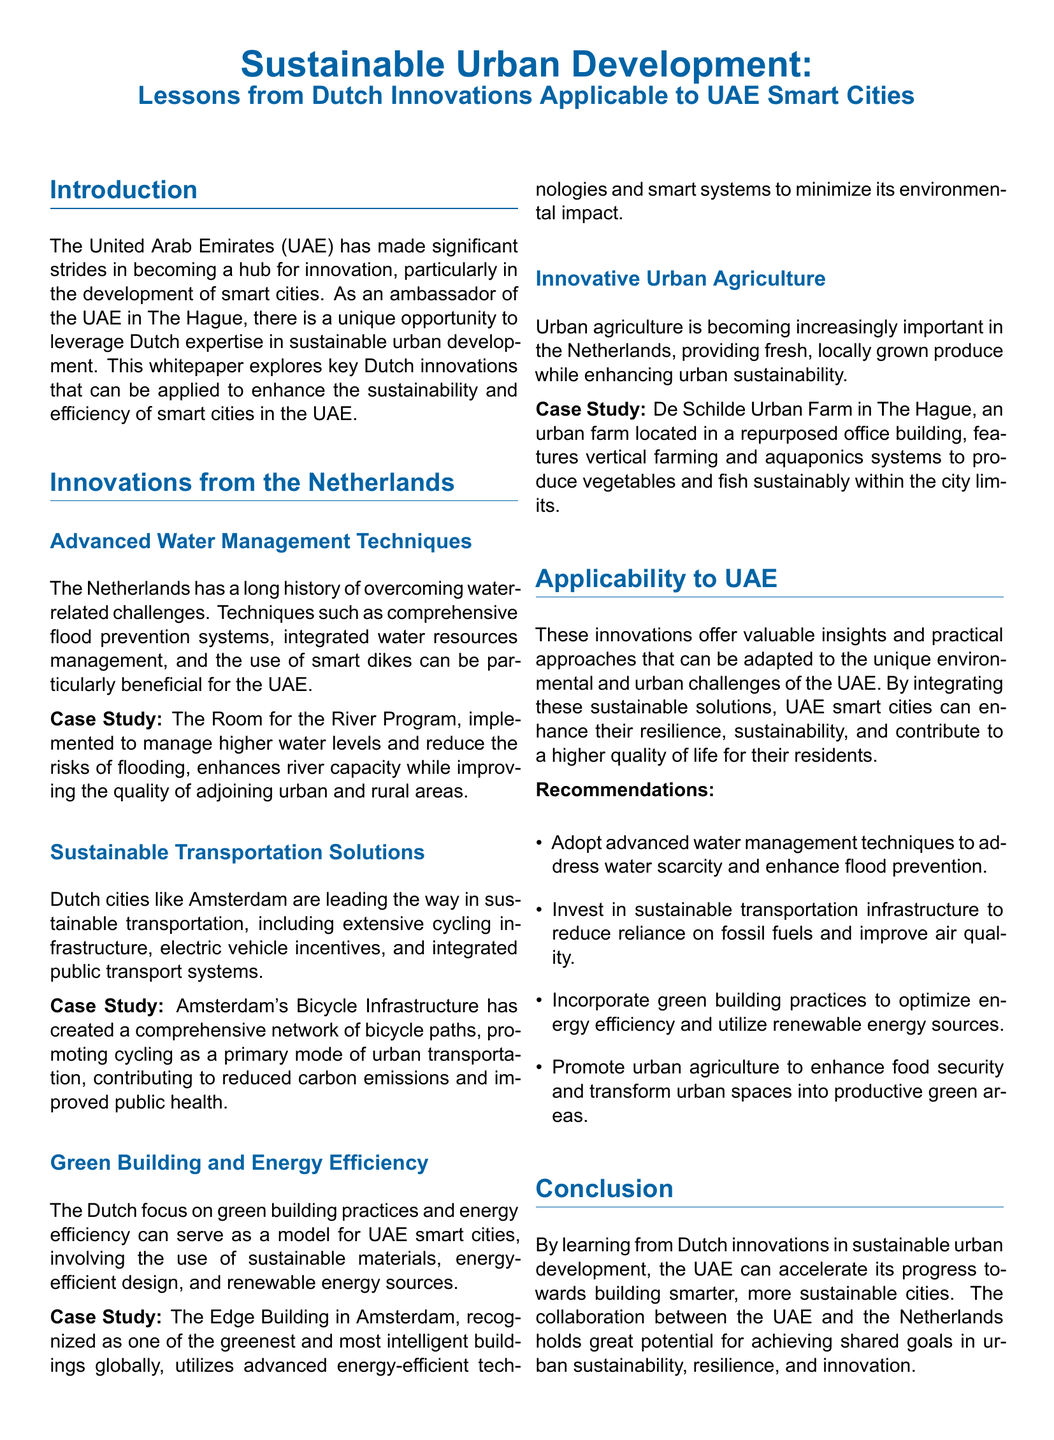What is the focus of the whitepaper? The whitepaper focuses on sustainable urban development and Dutch innovations applicable to UAE smart cities.
Answer: Sustainable urban development Which Dutch city is mentioned for its sustainable transportation solutions? The document cites Amsterdam as a leading city in sustainable transportation.
Answer: Amsterdam What advanced technique can address water scarcity in the UAE? The document suggests adopting advanced water management techniques to address water scarcity.
Answer: Advanced water management techniques What notable case study is mentioned for urban agriculture? The whitepaper references De Schilde Urban Farm as a case study for urban agriculture in The Hague.
Answer: De Schilde Urban Farm What is recommended to improve air quality in the UAE? The document recommends investing in sustainable transportation infrastructure to improve air quality.
Answer: Sustainable transportation infrastructure In which building does the Green Building case study take place? The case study for green building and energy efficiency refers to The Edge Building in Amsterdam.
Answer: The Edge Building What sustainable practice is suggested for enhancing food security? The document recommends promoting urban agriculture to enhance food security.
Answer: Urban agriculture Which program addresses flood prevention in the Netherlands? The Room for the River Program is cited as addressing flood prevention in the Netherlands.
Answer: Room for the River Program What is the ultimate goal of applying Dutch innovations in the UAE? The ultimate goal is to build smarter, more sustainable cities in the UAE.
Answer: Smarter, more sustainable cities 